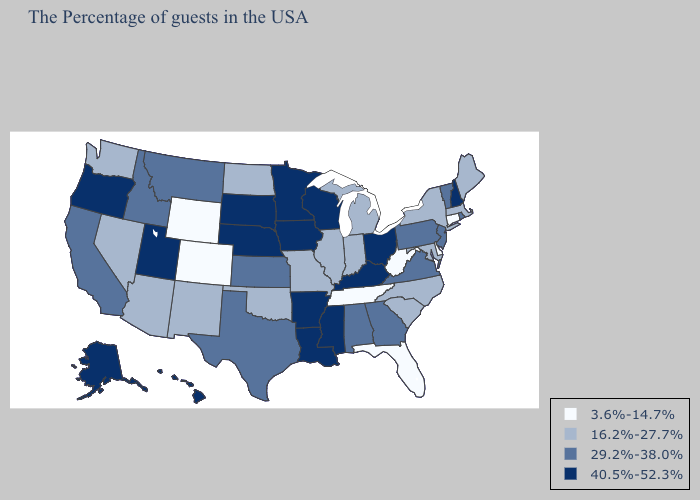What is the value of Florida?
Keep it brief. 3.6%-14.7%. Name the states that have a value in the range 29.2%-38.0%?
Concise answer only. Rhode Island, Vermont, New Jersey, Pennsylvania, Virginia, Georgia, Alabama, Kansas, Texas, Montana, Idaho, California. What is the highest value in the USA?
Be succinct. 40.5%-52.3%. Name the states that have a value in the range 29.2%-38.0%?
Be succinct. Rhode Island, Vermont, New Jersey, Pennsylvania, Virginia, Georgia, Alabama, Kansas, Texas, Montana, Idaho, California. Name the states that have a value in the range 16.2%-27.7%?
Write a very short answer. Maine, Massachusetts, New York, Maryland, North Carolina, South Carolina, Michigan, Indiana, Illinois, Missouri, Oklahoma, North Dakota, New Mexico, Arizona, Nevada, Washington. Name the states that have a value in the range 40.5%-52.3%?
Quick response, please. New Hampshire, Ohio, Kentucky, Wisconsin, Mississippi, Louisiana, Arkansas, Minnesota, Iowa, Nebraska, South Dakota, Utah, Oregon, Alaska, Hawaii. Name the states that have a value in the range 3.6%-14.7%?
Be succinct. Connecticut, Delaware, West Virginia, Florida, Tennessee, Wyoming, Colorado. What is the value of West Virginia?
Keep it brief. 3.6%-14.7%. Does the first symbol in the legend represent the smallest category?
Keep it brief. Yes. What is the highest value in states that border Nevada?
Write a very short answer. 40.5%-52.3%. What is the value of New Jersey?
Short answer required. 29.2%-38.0%. Does New Jersey have a higher value than Connecticut?
Write a very short answer. Yes. Does New Hampshire have the same value as California?
Keep it brief. No. What is the lowest value in the West?
Quick response, please. 3.6%-14.7%. Name the states that have a value in the range 3.6%-14.7%?
Give a very brief answer. Connecticut, Delaware, West Virginia, Florida, Tennessee, Wyoming, Colorado. 